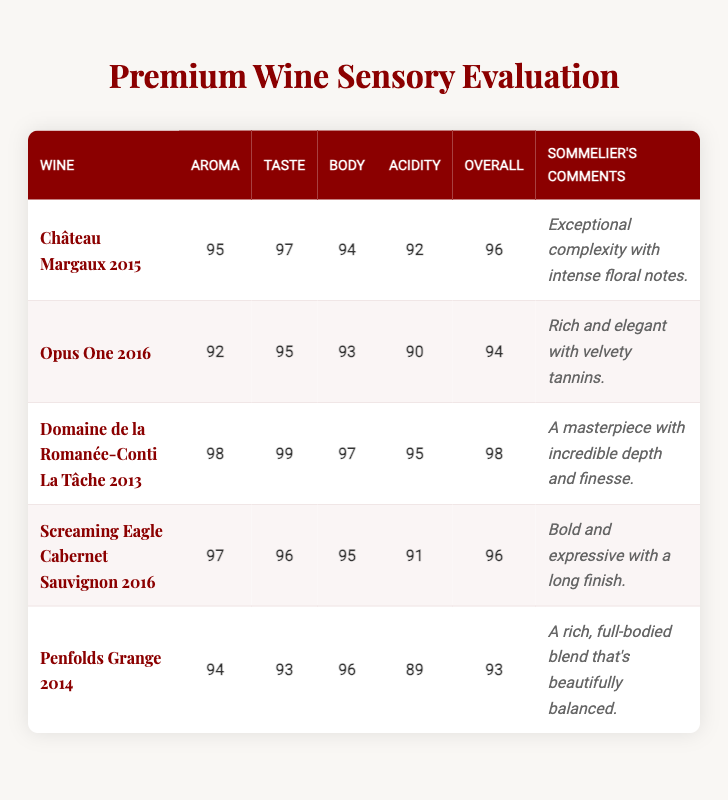What is the highest overall score among the wines listed? The wines listed have overall scores of 96, 94, 98, 96, and 93. The highest score among these is 98, attributed to Domaine de la Romanée-Conti La Tâche 2013.
Answer: 98 Which wine received the lowest score for acidity? The wines have acidity scores of 92, 90, 95, 91, and 89. The lowest score is 89, which belongs to Penfolds Grange 2014.
Answer: Penfolds Grange 2014 What is the average aroma score of the wines? To find the average aroma score, we need to add the aroma scores: 95 + 92 + 98 + 97 + 94 = 476. There are 5 wines, so the average aroma score is 476 / 5 = 95.2.
Answer: 95.2 Did Screaming Eagle Cabernet Sauvignon 2016 receive a higher score for body or acidity? Screaming Eagle Cabernet Sauvignon 2016 has a body score of 95 and an acidity score of 91. Since 95 is greater than 91, it received a higher score for body.
Answer: Yes Which wine has the most favorable comments from the sommeliers? The sommelier's comments indicate that Domaine de la Romanée-Conti La Tâche 2013 is described as "A masterpiece with incredible depth and finesse," which is very positive compared to the others.
Answer: Domaine de la Romanée-Conti La Tâche 2013 What is the difference in overall scores between Château Margaux 2015 and Opus One 2016? Château Margaux 2015 has an overall score of 96, while Opus One 2016 has a score of 94. The difference is 96 - 94 = 2.
Answer: 2 Is there any wine with an overall score of 95? No wine in the list has an overall score of 95. The overall scores are 96, 94, 98, 96, and 93.
Answer: No What wine has the highest taste score and what is that score? The taste scores of the wines are 97, 95, 99, 96, and 93. The highest score is 99, which belongs to Domaine de la Romanée-Conti La Tâche 2013.
Answer: Domaine de la Romanée-Conti La Tâche 2013, 99 